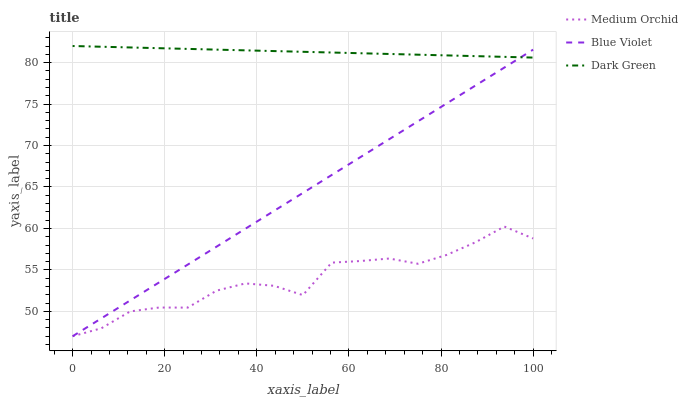Does Medium Orchid have the minimum area under the curve?
Answer yes or no. Yes. Does Dark Green have the maximum area under the curve?
Answer yes or no. Yes. Does Blue Violet have the minimum area under the curve?
Answer yes or no. No. Does Blue Violet have the maximum area under the curve?
Answer yes or no. No. Is Blue Violet the smoothest?
Answer yes or no. Yes. Is Medium Orchid the roughest?
Answer yes or no. Yes. Is Dark Green the smoothest?
Answer yes or no. No. Is Dark Green the roughest?
Answer yes or no. No. Does Medium Orchid have the lowest value?
Answer yes or no. Yes. Does Dark Green have the lowest value?
Answer yes or no. No. Does Dark Green have the highest value?
Answer yes or no. Yes. Does Blue Violet have the highest value?
Answer yes or no. No. Is Medium Orchid less than Dark Green?
Answer yes or no. Yes. Is Dark Green greater than Medium Orchid?
Answer yes or no. Yes. Does Blue Violet intersect Medium Orchid?
Answer yes or no. Yes. Is Blue Violet less than Medium Orchid?
Answer yes or no. No. Is Blue Violet greater than Medium Orchid?
Answer yes or no. No. Does Medium Orchid intersect Dark Green?
Answer yes or no. No. 